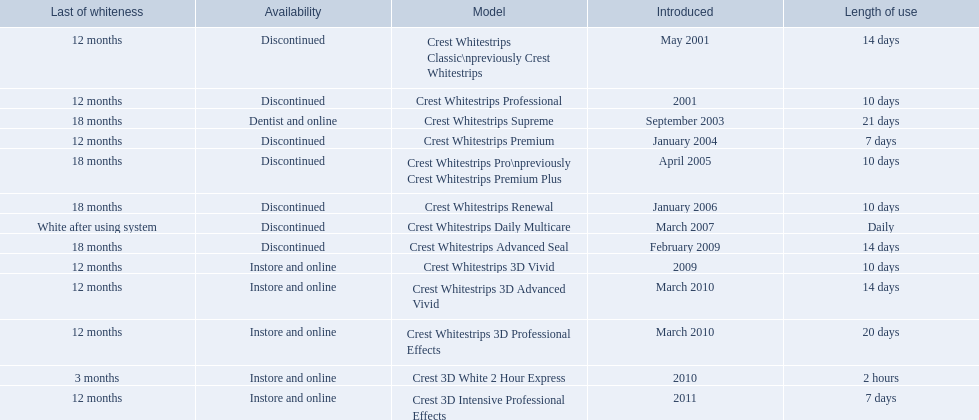What year did crest come out with crest white strips 3d vivid? 2009. Which crest product was also introduced he same year, but is now discontinued? Crest Whitestrips Advanced Seal. Help me parse the entirety of this table. {'header': ['Last of whiteness', 'Availability', 'Model', 'Introduced', 'Length of use'], 'rows': [['12 months', 'Discontinued', 'Crest Whitestrips Classic\\npreviously Crest Whitestrips', 'May 2001', '14 days'], ['12 months', 'Discontinued', 'Crest Whitestrips Professional', '2001', '10 days'], ['18 months', 'Dentist and online', 'Crest Whitestrips Supreme', 'September 2003', '21 days'], ['12 months', 'Discontinued', 'Crest Whitestrips Premium', 'January 2004', '7 days'], ['18 months', 'Discontinued', 'Crest Whitestrips Pro\\npreviously Crest Whitestrips Premium Plus', 'April 2005', '10 days'], ['18 months', 'Discontinued', 'Crest Whitestrips Renewal', 'January 2006', '10 days'], ['White after using system', 'Discontinued', 'Crest Whitestrips Daily Multicare', 'March 2007', 'Daily'], ['18 months', 'Discontinued', 'Crest Whitestrips Advanced Seal', 'February 2009', '14 days'], ['12 months', 'Instore and online', 'Crest Whitestrips 3D Vivid', '2009', '10 days'], ['12 months', 'Instore and online', 'Crest Whitestrips 3D Advanced Vivid', 'March 2010', '14 days'], ['12 months', 'Instore and online', 'Crest Whitestrips 3D Professional Effects', 'March 2010', '20 days'], ['3 months', 'Instore and online', 'Crest 3D White 2 Hour Express', '2010', '2 hours'], ['12 months', 'Instore and online', 'Crest 3D Intensive Professional Effects', '2011', '7 days']]} 